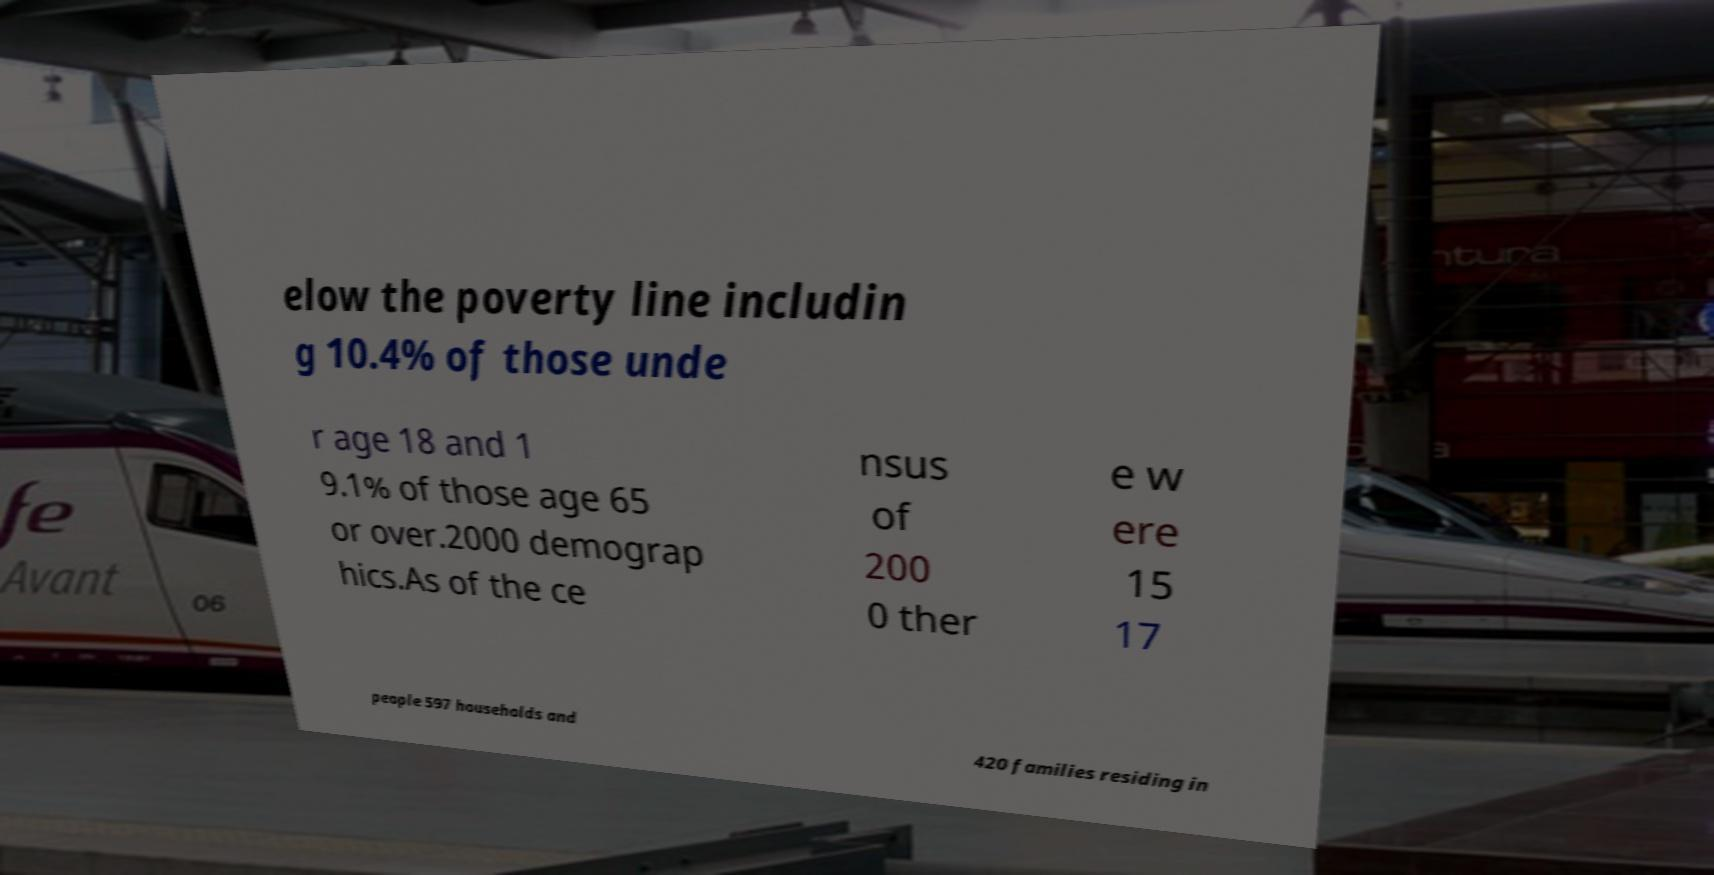Could you assist in decoding the text presented in this image and type it out clearly? elow the poverty line includin g 10.4% of those unde r age 18 and 1 9.1% of those age 65 or over.2000 demograp hics.As of the ce nsus of 200 0 ther e w ere 15 17 people 597 households and 420 families residing in 